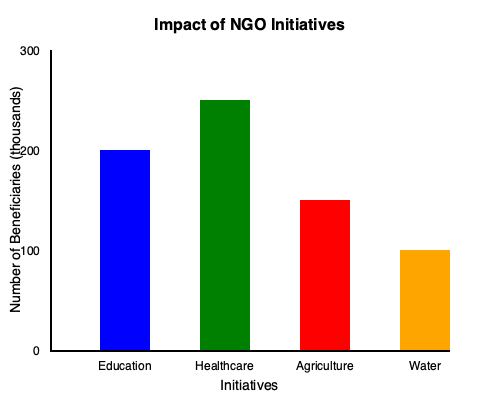Based on the bar graph showing the impact of different NGO initiatives, which initiative has reached the highest number of beneficiaries, and approximately how many thousands of people has it impacted? To answer this question, we need to analyze the bar graph:

1. The graph shows four initiatives: Education, Healthcare, Agriculture, and Water.
2. The y-axis represents the number of beneficiaries in thousands.
3. To determine which initiative has reached the highest number of beneficiaries, we need to identify the tallest bar:
   - Education (blue): reaches slightly above the 200,000 mark
   - Healthcare (green): reaches the 250,000 mark
   - Agriculture (red): reaches the 150,000 mark
   - Water (orange): reaches the 100,000 mark
4. The tallest bar corresponds to the Healthcare initiative.
5. To estimate the number of beneficiaries for Healthcare:
   - The bar reaches exactly at the 250,000 mark
   - Therefore, the Healthcare initiative has impacted approximately 250,000 people

Thus, the Healthcare initiative has reached the highest number of beneficiaries, impacting approximately 250 thousand people.
Answer: Healthcare, 250 thousand 